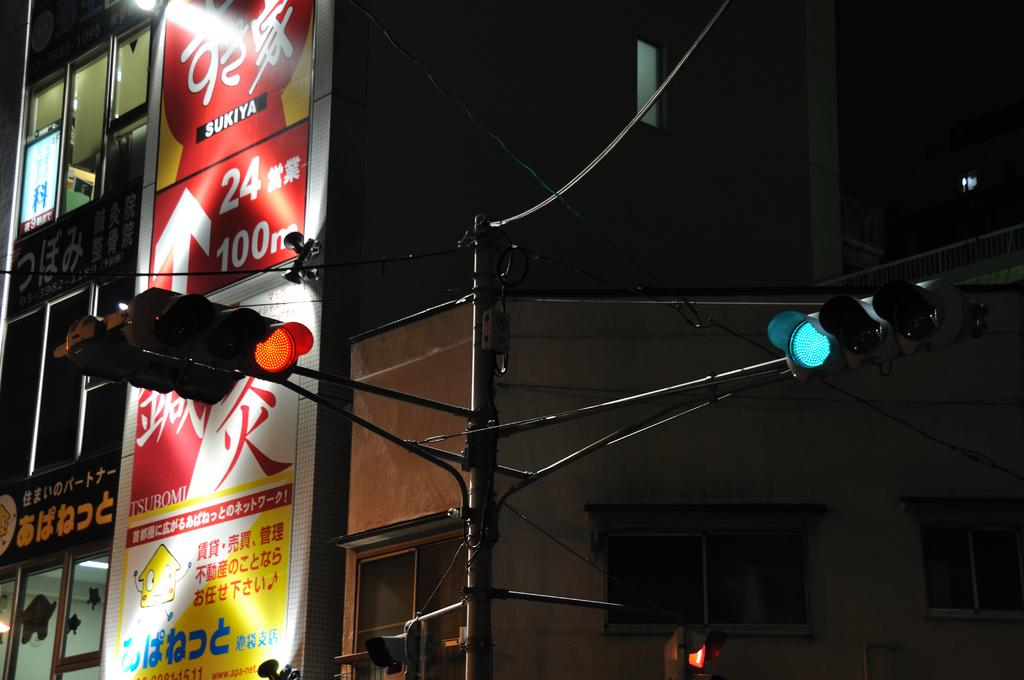<image>
Provide a brief description of the given image. The sign with the arrow pointing up has the numbers 24 and 100 next to it. 